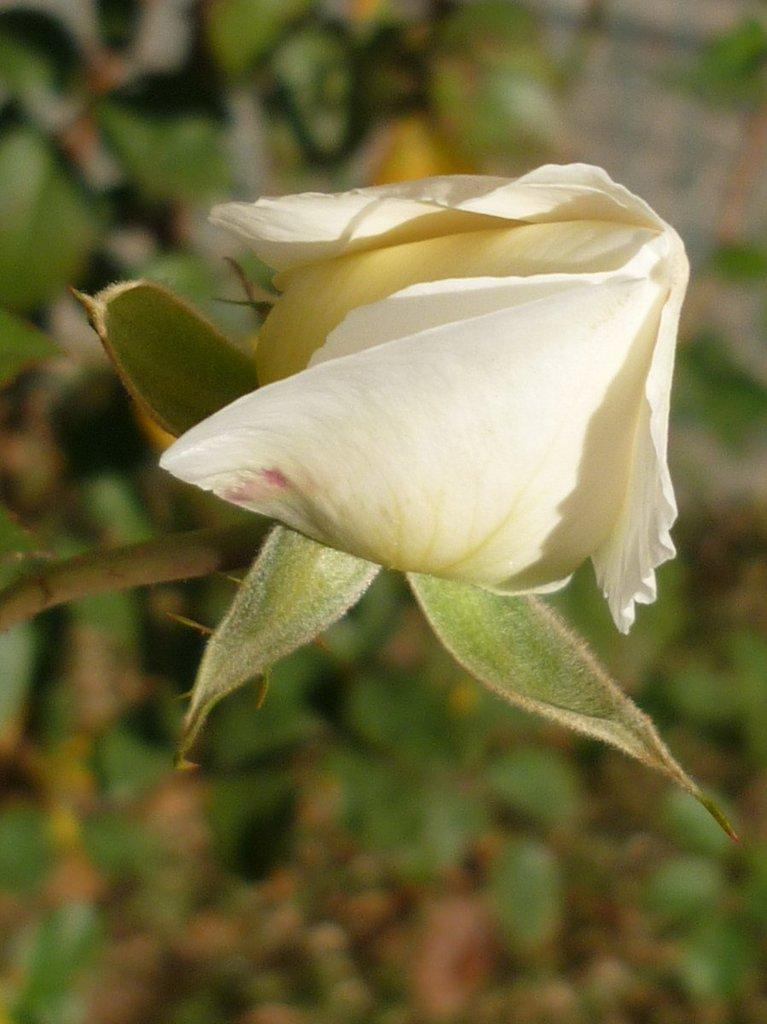What type of flower is visible in the image? There is a rose flower bud in the image. Can you describe the background of the image? The background of the image is blurred. What type of plant is covering the stove in the image? There is no plant or stove present in the image; it only features a rose flower bud with a blurred background. 